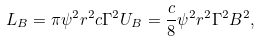<formula> <loc_0><loc_0><loc_500><loc_500>L _ { B } = \pi \psi ^ { 2 } r ^ { 2 } c \Gamma ^ { 2 } U _ { B } = \frac { c } { 8 } \psi ^ { 2 } r ^ { 2 } \Gamma ^ { 2 } B ^ { 2 } ,</formula> 